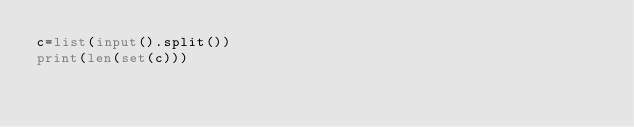<code> <loc_0><loc_0><loc_500><loc_500><_Python_>c=list(input().split())
print(len(set(c)))</code> 